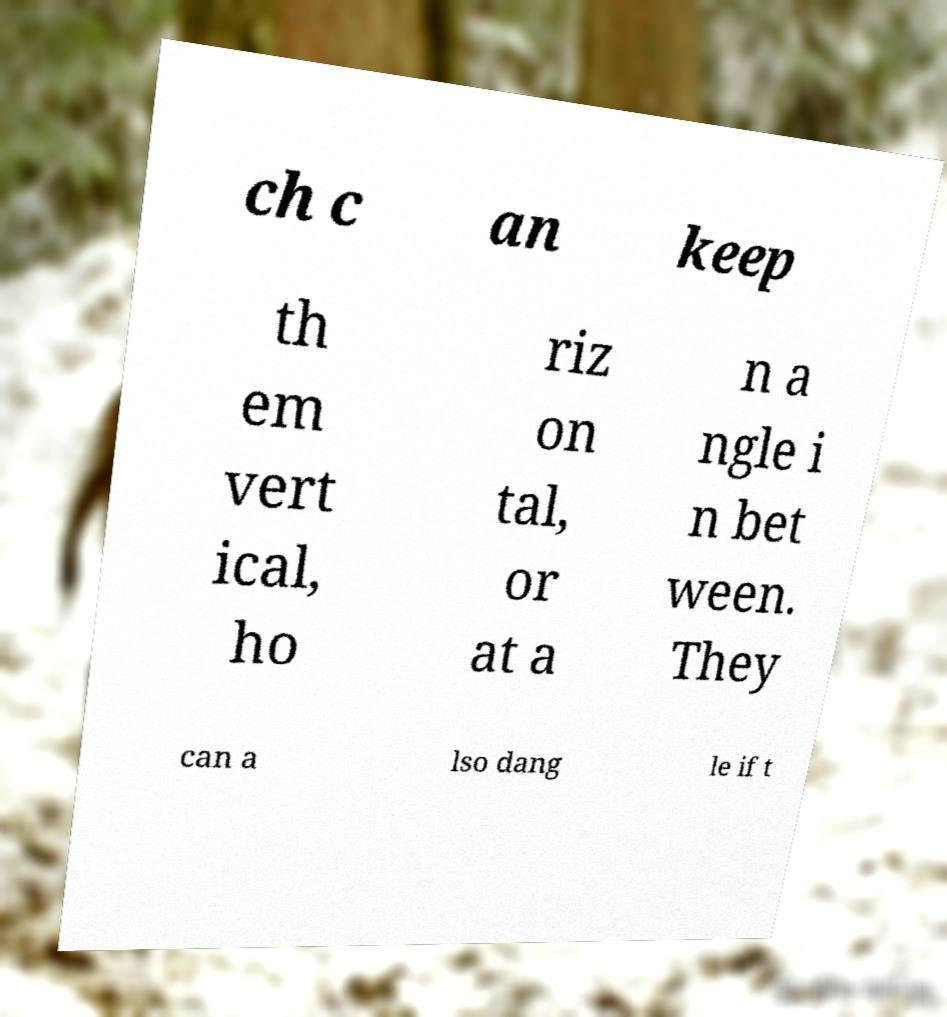I need the written content from this picture converted into text. Can you do that? ch c an keep th em vert ical, ho riz on tal, or at a n a ngle i n bet ween. They can a lso dang le if t 